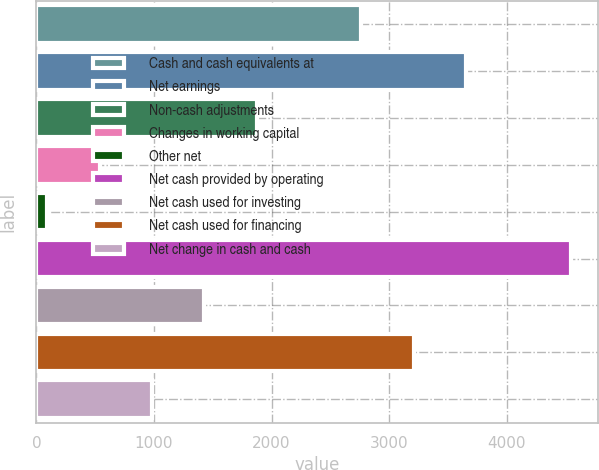<chart> <loc_0><loc_0><loc_500><loc_500><bar_chart><fcel>Cash and cash equivalents at<fcel>Net earnings<fcel>Non-cash adjustments<fcel>Changes in working capital<fcel>Other net<fcel>Net cash provided by operating<fcel>Net cash used for investing<fcel>Net cash used for financing<fcel>Net change in cash and cash<nl><fcel>2764.8<fcel>3655.4<fcel>1874.2<fcel>538.3<fcel>93<fcel>4546<fcel>1428.9<fcel>3210.1<fcel>983.6<nl></chart> 